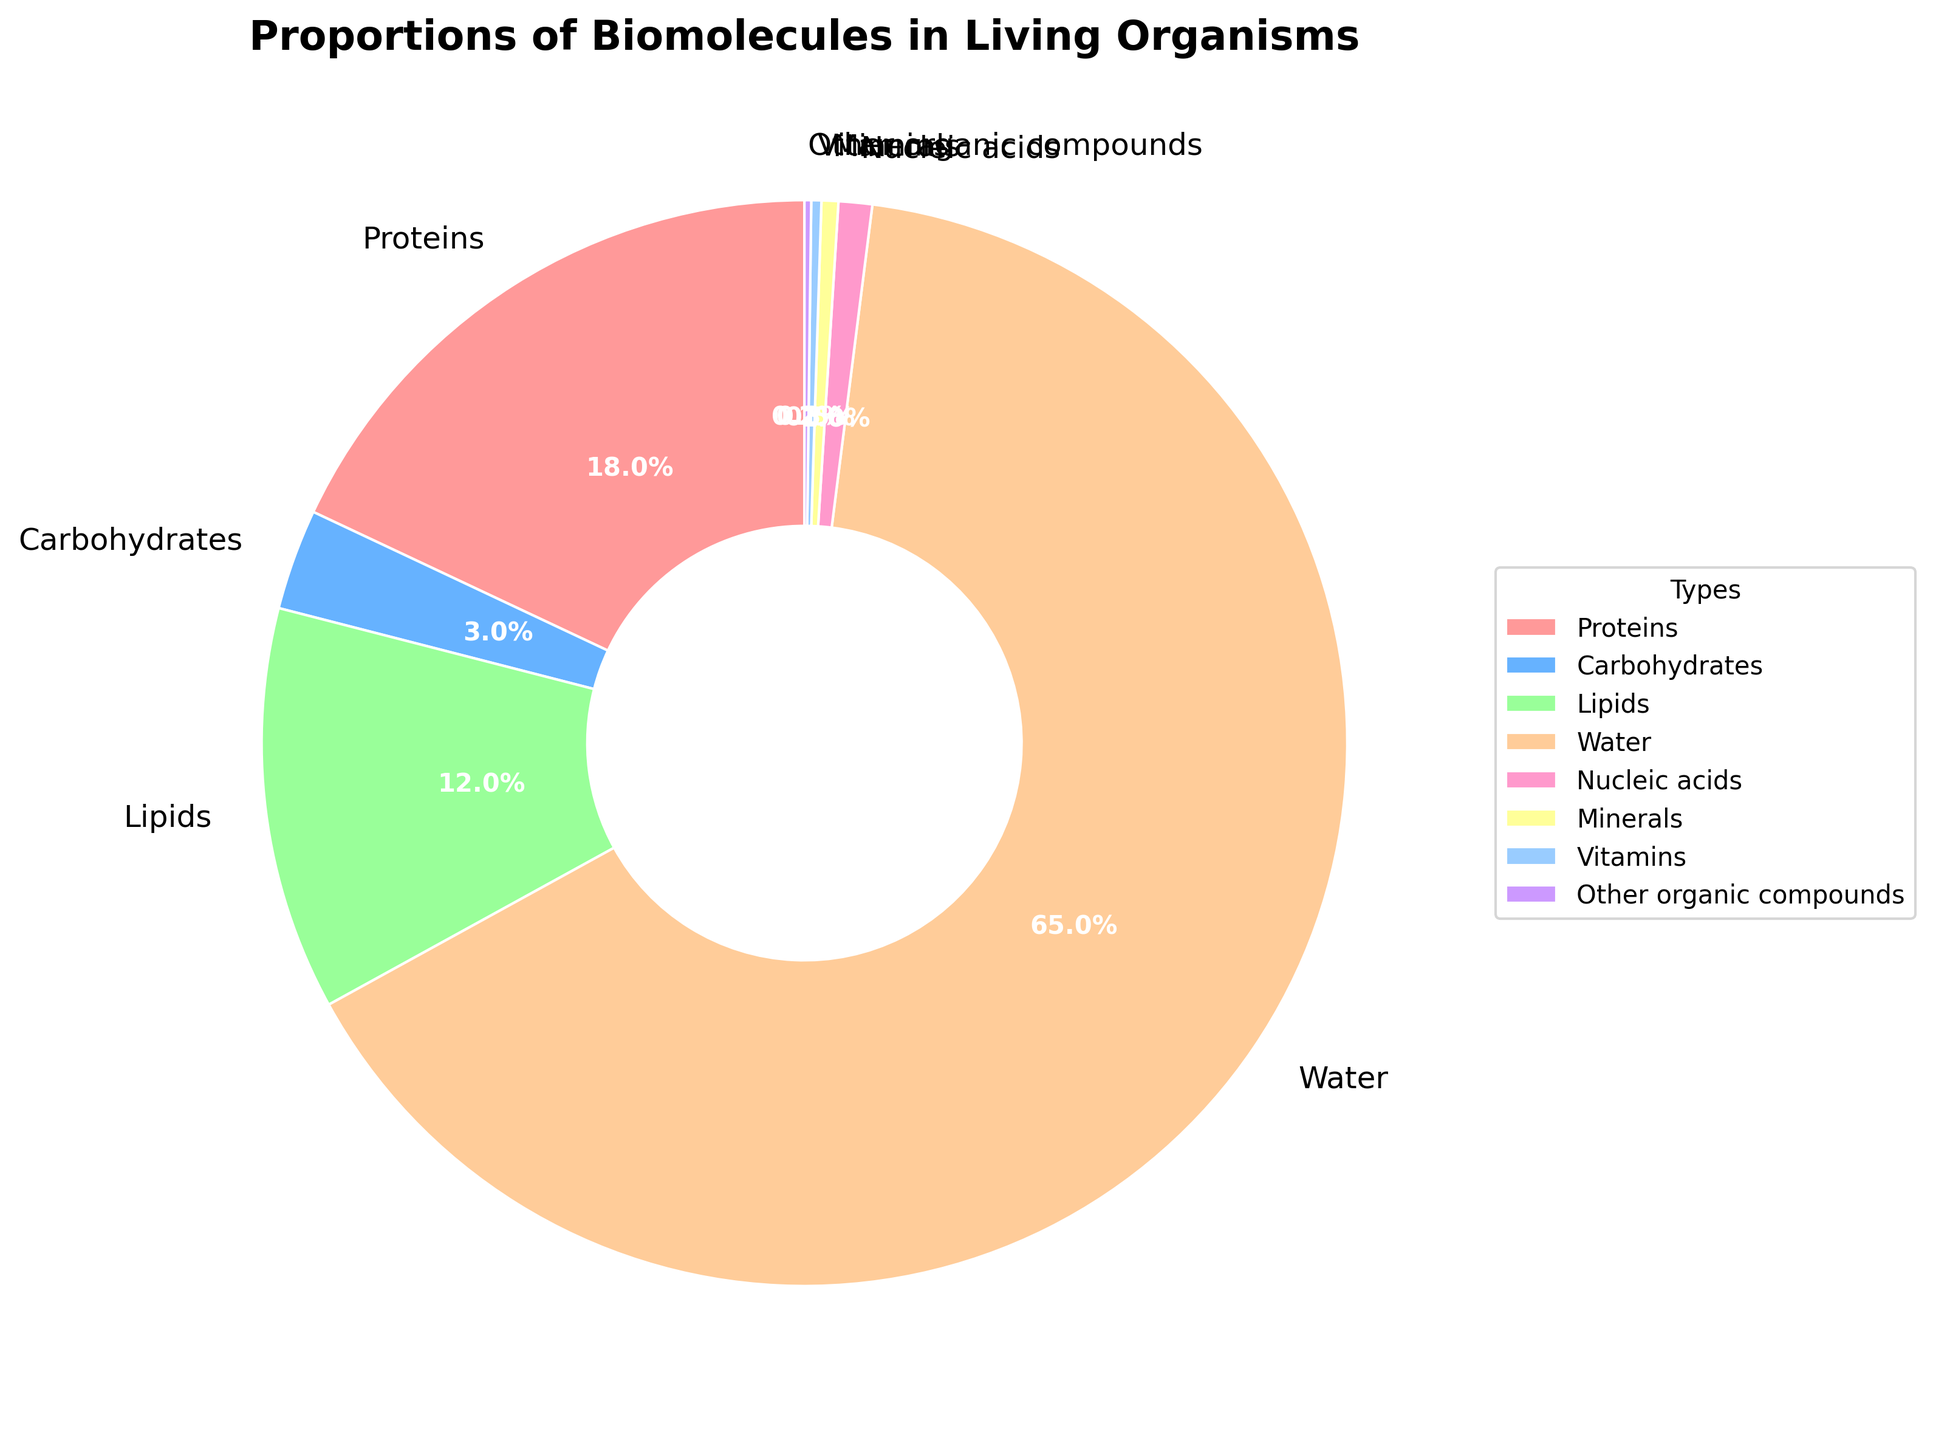Which type of biomolecule represents the largest proportion? By examining the pie chart, look for the segment that takes up the most space. Here, Water takes up the largest slice of the pie chart.
Answer: Water What is the combined percentage of Proteins and Lipids? Sum the percentages of Proteins (18%) and Lipids (12%) from the chart. 18 + 12 = 30
Answer: 30% Which type of biomolecule constitutes the smallest percentage? Identify the smallest slice in the pie chart, which is Other organic compounds at 0.2%.
Answer: Other organic compounds How much more percentage does Water have compared to Carbohydrates? Subtract the percentage of Carbohydrates (3%) from Water (65%). 65 - 3 = 62
Answer: 62% Do Proteins constitute a higher percentage than Lipids? Compare the percentage values of Proteins (18%) and Lipids (12%) in the chart. Yes, 18% is higher than 12%.
Answer: Yes Which section of the pie chart is represented by the color red? Identify the color red in the pie chart's legend or segments. The red section represents Proteins.
Answer: Proteins What is the combined percentage of Nucleic acids, Minerals, and Vitamins? Sum the percentages of Nucleic acids (1%), Minerals (0.5%), and Vitamins (0.3%). 1 + 0.5 + 0.3 = 1.8
Answer: 1.8% Is the percentage of Lipids greater than the combined percentage of Minerals, Vitamins, and Other organic compounds? Calculate the combined percentage of Minerals (0.5%), Vitamins (0.3%), and Other organic compounds (0.2%), which is 0.5 + 0.3 + 0.2 = 1. Then compare it to Lipids (12%). Yes, 12% is greater.
Answer: Yes What percentage more is Water compared to Lipids? Subtract the percentage of Lipids (12%) from Water (65%). 65 - 12 = 53
Answer: 53% Which biomolecule represents approximately 1% of the total composition? From the pie chart, Nucleic acids is the closest to 1%, with exactly 1% representation.
Answer: Nucleic acids 